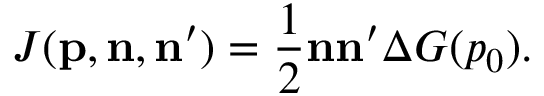Convert formula to latex. <formula><loc_0><loc_0><loc_500><loc_500>J ( { p , n , n } ^ { \prime } ) = \frac { 1 } { 2 } { n n } ^ { \prime } \Delta G ( p _ { 0 } ) .</formula> 